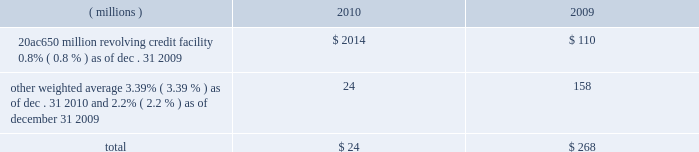Notes to the consolidated financial statements the credit agreement provides that loans will bear interest at rates based , at the company 2019s option , on one of two specified base rates plus a margin based on certain formulas defined in the credit agreement .
Additionally , the credit agreement contains a commitment fee on the amount of unused commitment under the credit agreement ranging from 0.125% ( 0.125 % ) to 0.625% ( 0.625 % ) per annum .
The applicable interest rate and the commitment fee will vary depending on the ratings established by standard & poor 2019s financial services llc and moody 2019s investor service inc .
For the company 2019s non-credit enhanced , long- term , senior , unsecured debt .
The credit agreement contains usual and customary restrictive covenants for facilities of its type , which include , with specified exceptions , limitations on the company 2019s ability to create liens or other encumbrances , to enter into sale and leaseback transactions and to enter into consolidations , mergers or transfers of all or substantially all of its assets .
The credit agreement also requires the company to maintain a ratio of total indebtedness to total capitalization , as defined in the credit agreement , of sixty percent or less .
The credit agreement contains customary events of default that would permit the lenders to accelerate the repayment of any loans , including the failure to make timely payments when due under the credit agreement or other material indebtedness , the failure to satisfy covenants contained in the credit agreement , a change in control of the company and specified events of bankruptcy and insolvency .
There were no amounts outstanding under the credit agreement at december 31 , on november 12 , 2010 , ppg completed a public offering of $ 250 million in aggregate principal amount of its 1.900% ( 1.900 % ) notes due 2016 ( the 201c2016 notes 201d ) , $ 500 million in aggregate principal amount of its 3.600% ( 3.600 % ) notes due 2020 ( the 201c2020 notes 201d ) and $ 250 million in aggregate principal amount of its 5.500% ( 5.500 % ) notes due 2040 ( the 201c2040 notes 201d ) .
These notes were issued pursuant to an indenture dated as of march 18 , 2008 ( the 201coriginal indenture 201d ) between the company and the bank of new york mellon trust company , n.a. , as trustee ( the 201ctrustee 201d ) , as supplemented by a first supplemental indenture dated as of march 18 , 2008 between the company and the trustee ( the 201cfirst supplemental indenture 201d ) and a second supplemental indenture dated as of november 12 , 2010 between the company and the trustee ( the 201csecond supplemental indenture 201d and , together with the original indenture and the first supplemental indenture , the 201cindenture 201d ) .
The company may issue additional debt from time to time pursuant to the original indenture .
The indenture governing these notes contains covenants that limit the company 2019s ability to , among other things , incur certain liens securing indebtedness , engage in certain sale-leaseback transactions , and enter into certain consolidations , mergers , conveyances , transfers or leases of all or substantially all the company 2019s assets .
The terms of these notes also require the company to make an offer to repurchase notes upon a change of control triggering event ( as defined in the second supplemental indenture ) at a price equal to 101% ( 101 % ) of their principal amount plus accrued and unpaid interest .
Cash proceeds from this notes offering was $ 983 million ( net of discount and issuance costs ) .
The discount and issuance costs related to these notes , which totaled $ 17 million , will be amortized to interest expense over the respective terms of the notes .
Ppg 2019s non-u.s .
Operations have uncommitted lines of credit totaling $ 791 million of which $ 31 million was used as of december 31 , 2010 .
These uncommitted lines of credit are subject to cancellation at any time and are generally not subject to any commitment fees .
Short-term debt outstanding as of december 31 , 2010 and 2009 , was as follows : ( millions ) 2010 2009 20ac650 million revolving credit facility , 0.8% ( 0.8 % ) as of dec .
31 , 2009 $ 2014 $ 110 other , weighted average 3.39% ( 3.39 % ) as of dec .
31 , 2010 and 2.2% ( 2.2 % ) as of december 31 , 2009 24 158 total $ 24 $ 268 ppg is in compliance with the restrictive covenants under its various credit agreements , loan agreements and indentures .
The company 2019s revolving credit agreements include a financial ratio covenant .
The covenant requires that the amount of total indebtedness not exceed 60% ( 60 % ) of the company 2019s total capitalization excluding the portion of accumulated other comprehensive income ( loss ) related to pensions and other postretirement benefit adjustments .
As of december 31 , 2010 , total indebtedness was 45% ( 45 % ) of the company 2019s total capitalization excluding the portion of accumulated other comprehensive income ( loss ) related to pensions and other postretirement benefit adjustments .
Additionally , substantially all of the company 2019s debt agreements contain customary cross- default provisions .
Those provisions generally provide that a default on a debt service payment of $ 10 million or more for longer than the grace period provided ( usually 10 days ) under one agreement may result in an event of default under other agreements .
None of the company 2019s primary debt obligations are secured or guaranteed by the company 2019s affiliates .
Interest payments in 2010 , 2009 and 2008 totaled $ 189 million , $ 201 million and $ 228 million , respectively .
2010 ppg annual report and form 10-k 43 .
Notes to the consolidated financial statements the credit agreement provides that loans will bear interest at rates based , at the company 2019s option , on one of two specified base rates plus a margin based on certain formulas defined in the credit agreement .
Additionally , the credit agreement contains a commitment fee on the amount of unused commitment under the credit agreement ranging from 0.125% ( 0.125 % ) to 0.625% ( 0.625 % ) per annum .
The applicable interest rate and the commitment fee will vary depending on the ratings established by standard & poor 2019s financial services llc and moody 2019s investor service inc .
For the company 2019s non-credit enhanced , long- term , senior , unsecured debt .
The credit agreement contains usual and customary restrictive covenants for facilities of its type , which include , with specified exceptions , limitations on the company 2019s ability to create liens or other encumbrances , to enter into sale and leaseback transactions and to enter into consolidations , mergers or transfers of all or substantially all of its assets .
The credit agreement also requires the company to maintain a ratio of total indebtedness to total capitalization , as defined in the credit agreement , of sixty percent or less .
The credit agreement contains customary events of default that would permit the lenders to accelerate the repayment of any loans , including the failure to make timely payments when due under the credit agreement or other material indebtedness , the failure to satisfy covenants contained in the credit agreement , a change in control of the company and specified events of bankruptcy and insolvency .
There were no amounts outstanding under the credit agreement at december 31 , on november 12 , 2010 , ppg completed a public offering of $ 250 million in aggregate principal amount of its 1.900% ( 1.900 % ) notes due 2016 ( the 201c2016 notes 201d ) , $ 500 million in aggregate principal amount of its 3.600% ( 3.600 % ) notes due 2020 ( the 201c2020 notes 201d ) and $ 250 million in aggregate principal amount of its 5.500% ( 5.500 % ) notes due 2040 ( the 201c2040 notes 201d ) .
These notes were issued pursuant to an indenture dated as of march 18 , 2008 ( the 201coriginal indenture 201d ) between the company and the bank of new york mellon trust company , n.a. , as trustee ( the 201ctrustee 201d ) , as supplemented by a first supplemental indenture dated as of march 18 , 2008 between the company and the trustee ( the 201cfirst supplemental indenture 201d ) and a second supplemental indenture dated as of november 12 , 2010 between the company and the trustee ( the 201csecond supplemental indenture 201d and , together with the original indenture and the first supplemental indenture , the 201cindenture 201d ) .
The company may issue additional debt from time to time pursuant to the original indenture .
The indenture governing these notes contains covenants that limit the company 2019s ability to , among other things , incur certain liens securing indebtedness , engage in certain sale-leaseback transactions , and enter into certain consolidations , mergers , conveyances , transfers or leases of all or substantially all the company 2019s assets .
The terms of these notes also require the company to make an offer to repurchase notes upon a change of control triggering event ( as defined in the second supplemental indenture ) at a price equal to 101% ( 101 % ) of their principal amount plus accrued and unpaid interest .
Cash proceeds from this notes offering was $ 983 million ( net of discount and issuance costs ) .
The discount and issuance costs related to these notes , which totaled $ 17 million , will be amortized to interest expense over the respective terms of the notes .
Ppg 2019s non-u.s .
Operations have uncommitted lines of credit totaling $ 791 million of which $ 31 million was used as of december 31 , 2010 .
These uncommitted lines of credit are subject to cancellation at any time and are generally not subject to any commitment fees .
Short-term debt outstanding as of december 31 , 2010 and 2009 , was as follows : ( millions ) 2010 2009 20ac650 million revolving credit facility , 0.8% ( 0.8 % ) as of dec .
31 , 2009 $ 2014 $ 110 other , weighted average 3.39% ( 3.39 % ) as of dec .
31 , 2010 and 2.2% ( 2.2 % ) as of december 31 , 2009 24 158 total $ 24 $ 268 ppg is in compliance with the restrictive covenants under its various credit agreements , loan agreements and indentures .
The company 2019s revolving credit agreements include a financial ratio covenant .
The covenant requires that the amount of total indebtedness not exceed 60% ( 60 % ) of the company 2019s total capitalization excluding the portion of accumulated other comprehensive income ( loss ) related to pensions and other postretirement benefit adjustments .
As of december 31 , 2010 , total indebtedness was 45% ( 45 % ) of the company 2019s total capitalization excluding the portion of accumulated other comprehensive income ( loss ) related to pensions and other postretirement benefit adjustments .
Additionally , substantially all of the company 2019s debt agreements contain customary cross- default provisions .
Those provisions generally provide that a default on a debt service payment of $ 10 million or more for longer than the grace period provided ( usually 10 days ) under one agreement may result in an event of default under other agreements .
None of the company 2019s primary debt obligations are secured or guaranteed by the company 2019s affiliates .
Interest payments in 2010 , 2009 and 2008 totaled $ 189 million , $ 201 million and $ 228 million , respectively .
2010 ppg annual report and form 10-k 43 .
What would 2011 interest payments be based on the rate of change in 2009 to 2010? 
Computations: (189 * (189 / 201))
Answer: 177.71642. Notes to the consolidated financial statements the credit agreement provides that loans will bear interest at rates based , at the company 2019s option , on one of two specified base rates plus a margin based on certain formulas defined in the credit agreement .
Additionally , the credit agreement contains a commitment fee on the amount of unused commitment under the credit agreement ranging from 0.125% ( 0.125 % ) to 0.625% ( 0.625 % ) per annum .
The applicable interest rate and the commitment fee will vary depending on the ratings established by standard & poor 2019s financial services llc and moody 2019s investor service inc .
For the company 2019s non-credit enhanced , long- term , senior , unsecured debt .
The credit agreement contains usual and customary restrictive covenants for facilities of its type , which include , with specified exceptions , limitations on the company 2019s ability to create liens or other encumbrances , to enter into sale and leaseback transactions and to enter into consolidations , mergers or transfers of all or substantially all of its assets .
The credit agreement also requires the company to maintain a ratio of total indebtedness to total capitalization , as defined in the credit agreement , of sixty percent or less .
The credit agreement contains customary events of default that would permit the lenders to accelerate the repayment of any loans , including the failure to make timely payments when due under the credit agreement or other material indebtedness , the failure to satisfy covenants contained in the credit agreement , a change in control of the company and specified events of bankruptcy and insolvency .
There were no amounts outstanding under the credit agreement at december 31 , on november 12 , 2010 , ppg completed a public offering of $ 250 million in aggregate principal amount of its 1.900% ( 1.900 % ) notes due 2016 ( the 201c2016 notes 201d ) , $ 500 million in aggregate principal amount of its 3.600% ( 3.600 % ) notes due 2020 ( the 201c2020 notes 201d ) and $ 250 million in aggregate principal amount of its 5.500% ( 5.500 % ) notes due 2040 ( the 201c2040 notes 201d ) .
These notes were issued pursuant to an indenture dated as of march 18 , 2008 ( the 201coriginal indenture 201d ) between the company and the bank of new york mellon trust company , n.a. , as trustee ( the 201ctrustee 201d ) , as supplemented by a first supplemental indenture dated as of march 18 , 2008 between the company and the trustee ( the 201cfirst supplemental indenture 201d ) and a second supplemental indenture dated as of november 12 , 2010 between the company and the trustee ( the 201csecond supplemental indenture 201d and , together with the original indenture and the first supplemental indenture , the 201cindenture 201d ) .
The company may issue additional debt from time to time pursuant to the original indenture .
The indenture governing these notes contains covenants that limit the company 2019s ability to , among other things , incur certain liens securing indebtedness , engage in certain sale-leaseback transactions , and enter into certain consolidations , mergers , conveyances , transfers or leases of all or substantially all the company 2019s assets .
The terms of these notes also require the company to make an offer to repurchase notes upon a change of control triggering event ( as defined in the second supplemental indenture ) at a price equal to 101% ( 101 % ) of their principal amount plus accrued and unpaid interest .
Cash proceeds from this notes offering was $ 983 million ( net of discount and issuance costs ) .
The discount and issuance costs related to these notes , which totaled $ 17 million , will be amortized to interest expense over the respective terms of the notes .
Ppg 2019s non-u.s .
Operations have uncommitted lines of credit totaling $ 791 million of which $ 31 million was used as of december 31 , 2010 .
These uncommitted lines of credit are subject to cancellation at any time and are generally not subject to any commitment fees .
Short-term debt outstanding as of december 31 , 2010 and 2009 , was as follows : ( millions ) 2010 2009 20ac650 million revolving credit facility , 0.8% ( 0.8 % ) as of dec .
31 , 2009 $ 2014 $ 110 other , weighted average 3.39% ( 3.39 % ) as of dec .
31 , 2010 and 2.2% ( 2.2 % ) as of december 31 , 2009 24 158 total $ 24 $ 268 ppg is in compliance with the restrictive covenants under its various credit agreements , loan agreements and indentures .
The company 2019s revolving credit agreements include a financial ratio covenant .
The covenant requires that the amount of total indebtedness not exceed 60% ( 60 % ) of the company 2019s total capitalization excluding the portion of accumulated other comprehensive income ( loss ) related to pensions and other postretirement benefit adjustments .
As of december 31 , 2010 , total indebtedness was 45% ( 45 % ) of the company 2019s total capitalization excluding the portion of accumulated other comprehensive income ( loss ) related to pensions and other postretirement benefit adjustments .
Additionally , substantially all of the company 2019s debt agreements contain customary cross- default provisions .
Those provisions generally provide that a default on a debt service payment of $ 10 million or more for longer than the grace period provided ( usually 10 days ) under one agreement may result in an event of default under other agreements .
None of the company 2019s primary debt obligations are secured or guaranteed by the company 2019s affiliates .
Interest payments in 2010 , 2009 and 2008 totaled $ 189 million , $ 201 million and $ 228 million , respectively .
2010 ppg annual report and form 10-k 43 .
Notes to the consolidated financial statements the credit agreement provides that loans will bear interest at rates based , at the company 2019s option , on one of two specified base rates plus a margin based on certain formulas defined in the credit agreement .
Additionally , the credit agreement contains a commitment fee on the amount of unused commitment under the credit agreement ranging from 0.125% ( 0.125 % ) to 0.625% ( 0.625 % ) per annum .
The applicable interest rate and the commitment fee will vary depending on the ratings established by standard & poor 2019s financial services llc and moody 2019s investor service inc .
For the company 2019s non-credit enhanced , long- term , senior , unsecured debt .
The credit agreement contains usual and customary restrictive covenants for facilities of its type , which include , with specified exceptions , limitations on the company 2019s ability to create liens or other encumbrances , to enter into sale and leaseback transactions and to enter into consolidations , mergers or transfers of all or substantially all of its assets .
The credit agreement also requires the company to maintain a ratio of total indebtedness to total capitalization , as defined in the credit agreement , of sixty percent or less .
The credit agreement contains customary events of default that would permit the lenders to accelerate the repayment of any loans , including the failure to make timely payments when due under the credit agreement or other material indebtedness , the failure to satisfy covenants contained in the credit agreement , a change in control of the company and specified events of bankruptcy and insolvency .
There were no amounts outstanding under the credit agreement at december 31 , on november 12 , 2010 , ppg completed a public offering of $ 250 million in aggregate principal amount of its 1.900% ( 1.900 % ) notes due 2016 ( the 201c2016 notes 201d ) , $ 500 million in aggregate principal amount of its 3.600% ( 3.600 % ) notes due 2020 ( the 201c2020 notes 201d ) and $ 250 million in aggregate principal amount of its 5.500% ( 5.500 % ) notes due 2040 ( the 201c2040 notes 201d ) .
These notes were issued pursuant to an indenture dated as of march 18 , 2008 ( the 201coriginal indenture 201d ) between the company and the bank of new york mellon trust company , n.a. , as trustee ( the 201ctrustee 201d ) , as supplemented by a first supplemental indenture dated as of march 18 , 2008 between the company and the trustee ( the 201cfirst supplemental indenture 201d ) and a second supplemental indenture dated as of november 12 , 2010 between the company and the trustee ( the 201csecond supplemental indenture 201d and , together with the original indenture and the first supplemental indenture , the 201cindenture 201d ) .
The company may issue additional debt from time to time pursuant to the original indenture .
The indenture governing these notes contains covenants that limit the company 2019s ability to , among other things , incur certain liens securing indebtedness , engage in certain sale-leaseback transactions , and enter into certain consolidations , mergers , conveyances , transfers or leases of all or substantially all the company 2019s assets .
The terms of these notes also require the company to make an offer to repurchase notes upon a change of control triggering event ( as defined in the second supplemental indenture ) at a price equal to 101% ( 101 % ) of their principal amount plus accrued and unpaid interest .
Cash proceeds from this notes offering was $ 983 million ( net of discount and issuance costs ) .
The discount and issuance costs related to these notes , which totaled $ 17 million , will be amortized to interest expense over the respective terms of the notes .
Ppg 2019s non-u.s .
Operations have uncommitted lines of credit totaling $ 791 million of which $ 31 million was used as of december 31 , 2010 .
These uncommitted lines of credit are subject to cancellation at any time and are generally not subject to any commitment fees .
Short-term debt outstanding as of december 31 , 2010 and 2009 , was as follows : ( millions ) 2010 2009 20ac650 million revolving credit facility , 0.8% ( 0.8 % ) as of dec .
31 , 2009 $ 2014 $ 110 other , weighted average 3.39% ( 3.39 % ) as of dec .
31 , 2010 and 2.2% ( 2.2 % ) as of december 31 , 2009 24 158 total $ 24 $ 268 ppg is in compliance with the restrictive covenants under its various credit agreements , loan agreements and indentures .
The company 2019s revolving credit agreements include a financial ratio covenant .
The covenant requires that the amount of total indebtedness not exceed 60% ( 60 % ) of the company 2019s total capitalization excluding the portion of accumulated other comprehensive income ( loss ) related to pensions and other postretirement benefit adjustments .
As of december 31 , 2010 , total indebtedness was 45% ( 45 % ) of the company 2019s total capitalization excluding the portion of accumulated other comprehensive income ( loss ) related to pensions and other postretirement benefit adjustments .
Additionally , substantially all of the company 2019s debt agreements contain customary cross- default provisions .
Those provisions generally provide that a default on a debt service payment of $ 10 million or more for longer than the grace period provided ( usually 10 days ) under one agreement may result in an event of default under other agreements .
None of the company 2019s primary debt obligations are secured or guaranteed by the company 2019s affiliates .
Interest payments in 2010 , 2009 and 2008 totaled $ 189 million , $ 201 million and $ 228 million , respectively .
2010 ppg annual report and form 10-k 43 .
What was the change in millions of interest payments from 2009 to 2010? 
Computations: (189 - 201)
Answer: -12.0. 